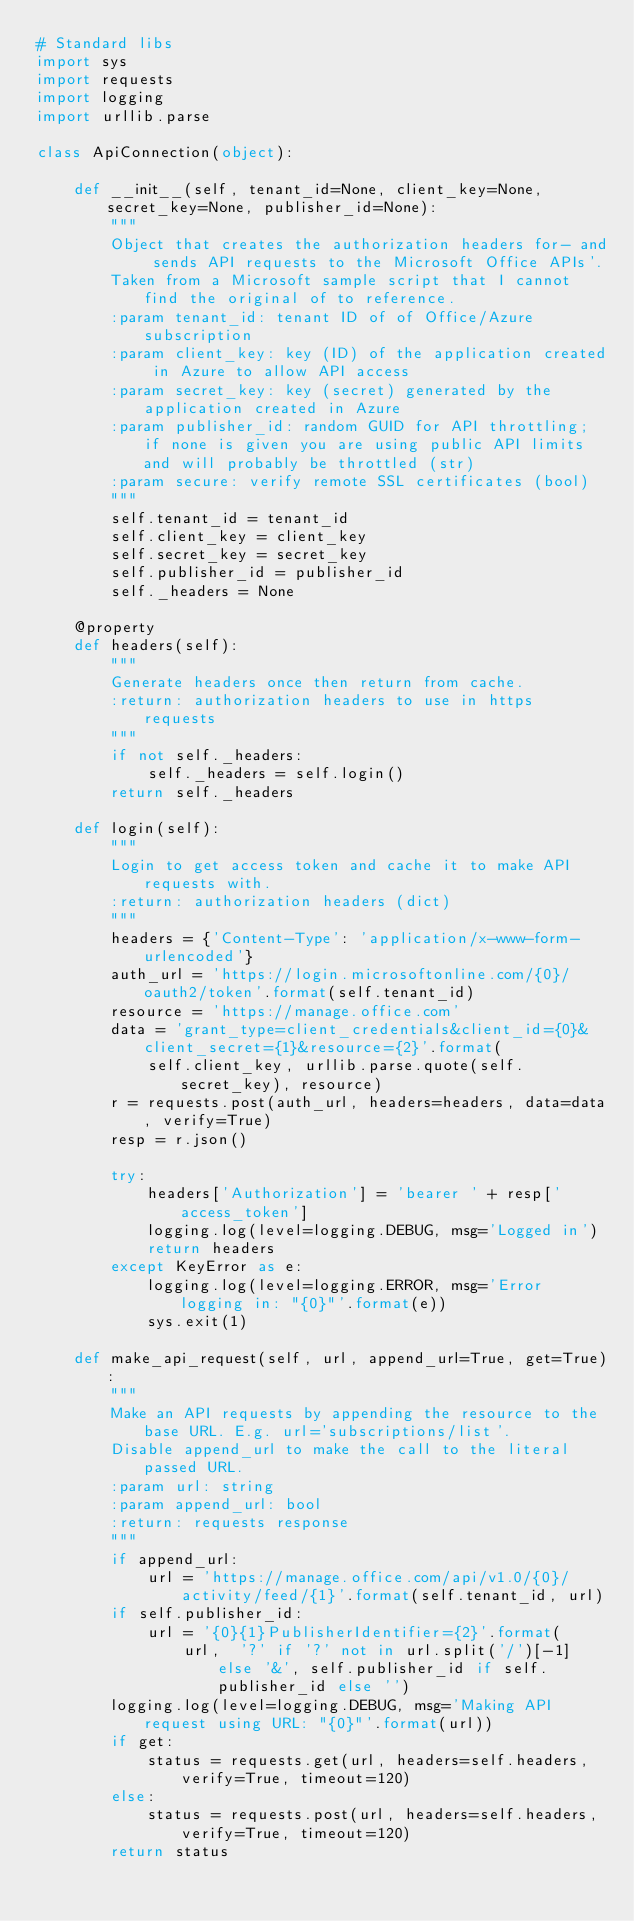Convert code to text. <code><loc_0><loc_0><loc_500><loc_500><_Python_># Standard libs
import sys
import requests
import logging
import urllib.parse

class ApiConnection(object):

    def __init__(self, tenant_id=None, client_key=None, secret_key=None, publisher_id=None):
        """
        Object that creates the authorization headers for- and sends API requests to the Microsoft Office APIs'.
        Taken from a Microsoft sample script that I cannot find the original of to reference.
        :param tenant_id: tenant ID of of Office/Azure subscription
        :param client_key: key (ID) of the application created in Azure to allow API access
        :param secret_key: key (secret) generated by the application created in Azure
        :param publisher_id: random GUID for API throttling; if none is given you are using public API limits and will probably be throttled (str)
        :param secure: verify remote SSL certificates (bool)
        """
        self.tenant_id = tenant_id
        self.client_key = client_key
        self.secret_key = secret_key
        self.publisher_id = publisher_id
        self._headers = None

    @property
    def headers(self):
        """
        Generate headers once then return from cache.
        :return: authorization headers to use in https requests
        """
        if not self._headers:
            self._headers = self.login()
        return self._headers

    def login(self):
        """
        Login to get access token and cache it to make API requests with.
        :return: authorization headers (dict)
        """
        headers = {'Content-Type': 'application/x-www-form-urlencoded'}
        auth_url = 'https://login.microsoftonline.com/{0}/oauth2/token'.format(self.tenant_id)
        resource = 'https://manage.office.com'
        data = 'grant_type=client_credentials&client_id={0}&client_secret={1}&resource={2}'.format(
            self.client_key, urllib.parse.quote(self.secret_key), resource)
        r = requests.post(auth_url, headers=headers, data=data, verify=True)
        resp = r.json()

        try:
            headers['Authorization'] = 'bearer ' + resp['access_token']
            logging.log(level=logging.DEBUG, msg='Logged in')
            return headers
        except KeyError as e:
            logging.log(level=logging.ERROR, msg='Error logging in: "{0}"'.format(e))
            sys.exit(1)

    def make_api_request(self, url, append_url=True, get=True):
        """
        Make an API requests by appending the resource to the base URL. E.g. url='subscriptions/list'.
        Disable append_url to make the call to the literal passed URL.
        :param url: string
        :param append_url: bool
        :return: requests response
        """
        if append_url:
            url = 'https://manage.office.com/api/v1.0/{0}/activity/feed/{1}'.format(self.tenant_id, url)
        if self.publisher_id:
            url = '{0}{1}PublisherIdentifier={2}'.format(
                url,  '?' if '?' not in url.split('/')[-1] else '&', self.publisher_id if self.publisher_id else '')
        logging.log(level=logging.DEBUG, msg='Making API request using URL: "{0}"'.format(url))
        if get:
            status = requests.get(url, headers=self.headers, verify=True, timeout=120)
        else:
            status = requests.post(url, headers=self.headers, verify=True, timeout=120)
        return status


</code> 